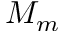Convert formula to latex. <formula><loc_0><loc_0><loc_500><loc_500>M _ { m }</formula> 